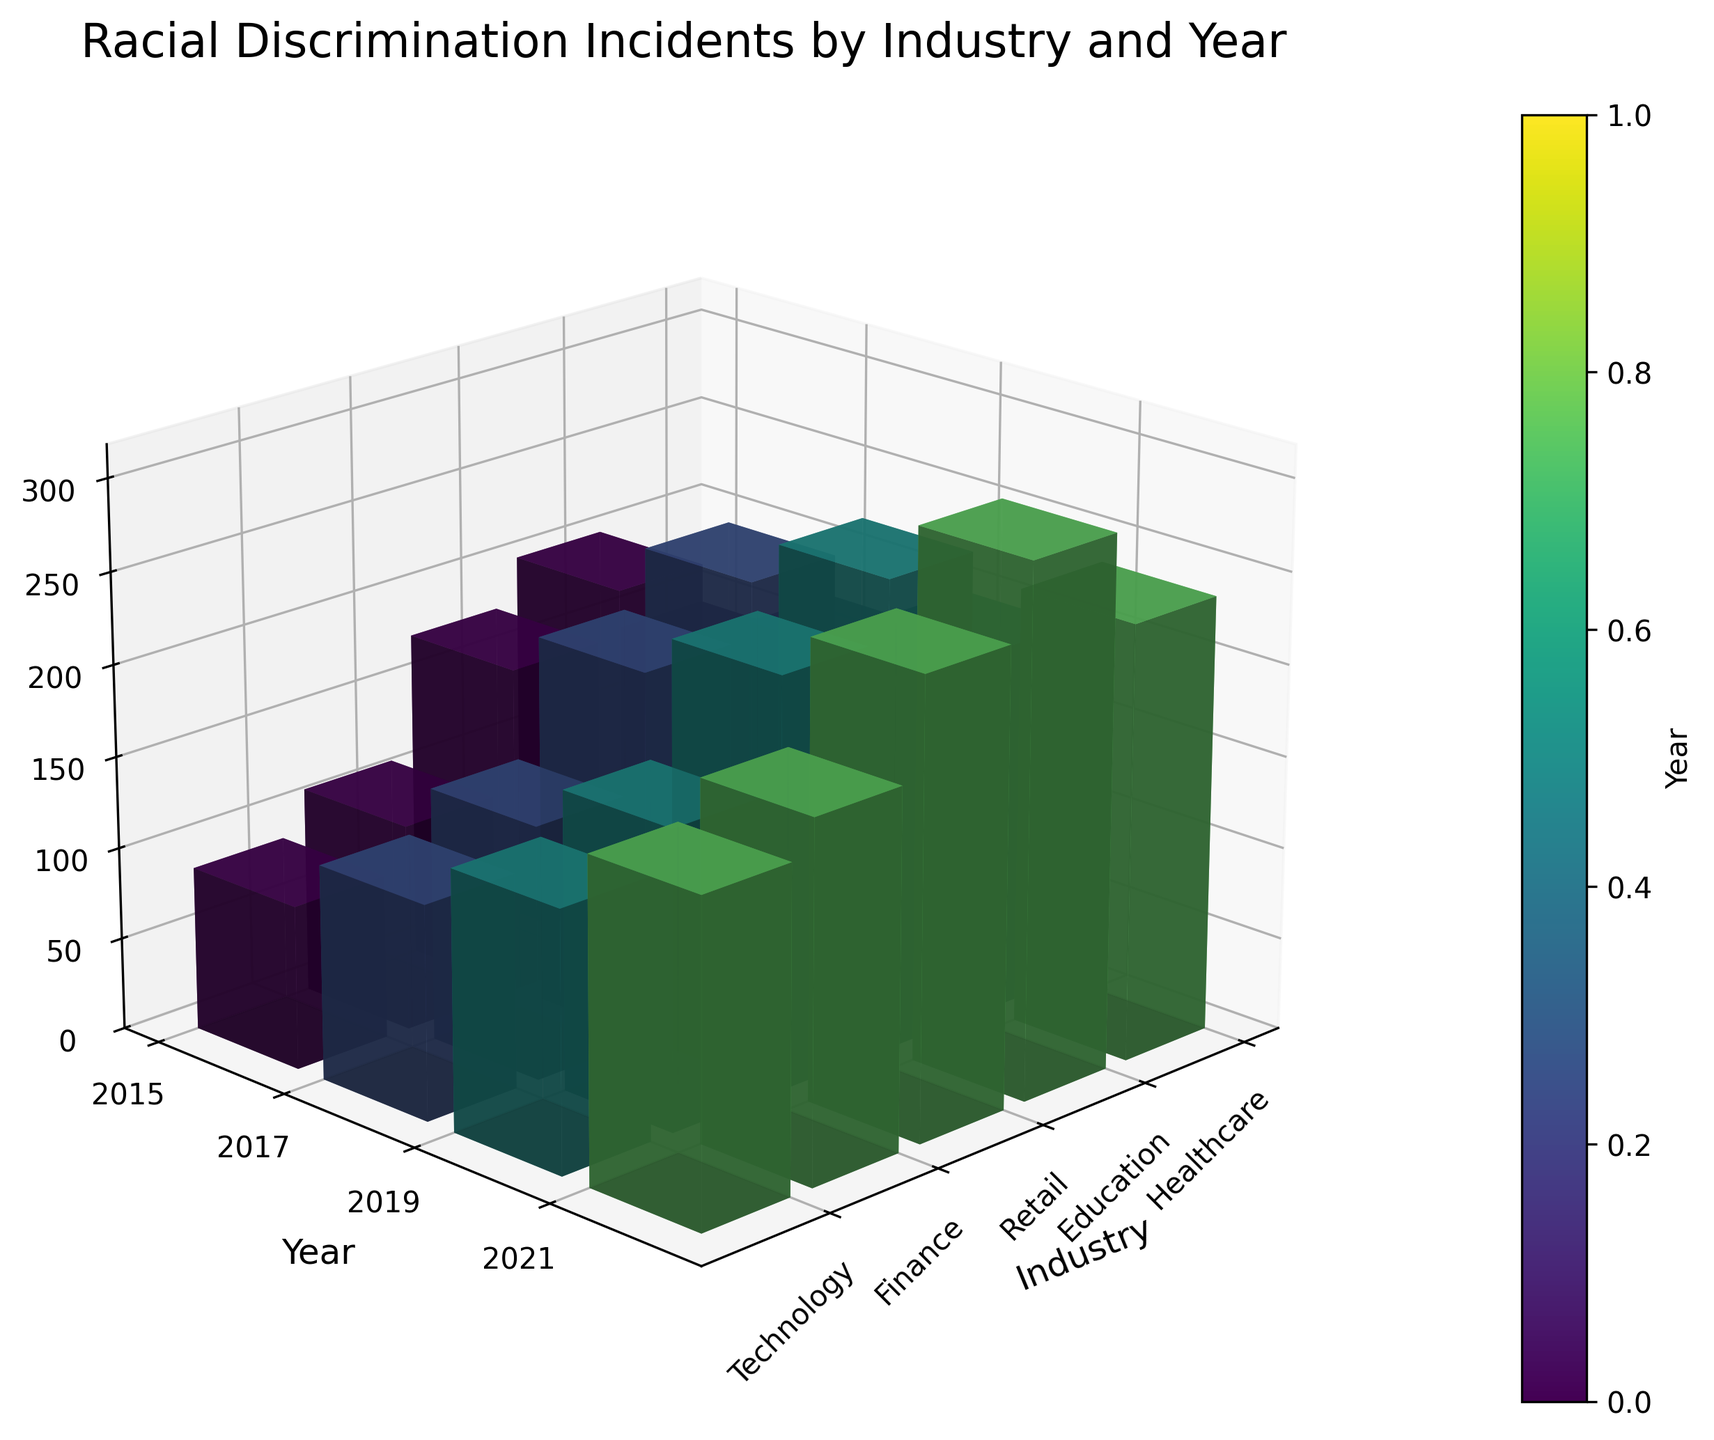What is the title of the plot? The title is usually located at the top of the figure. In this case, it reads "Racial Discrimination Incidents by Industry and Year".
Answer: Racial Discrimination Incidents by Industry and Year Which industry had the highest reported incidents in 2021? By observing the height of the bars in the plot labeled 2021, Education has the highest bar among the industries.
Answer: Education How does the number of reported incidents in Technology compare between 2015 and 2021? Look at the bars for Technology in both years. In 2015, the height corresponds to 89 incidents, whereas in 2021, it is 176 incidents.
Answer: Increased Which industry saw the largest increase in reported incidents from 2015 to 2021? Calculate the difference in incidents between 2021 and 2015 for each industry. Education increased from 203 to 289 (86), Healthcare from 145 to 237 (92), Retail from 178 to 249 (71), Finance from 112 to 195 (83), and Technology from 89 to 176 (87). The largest increase was for Healthcare with a difference of 92.
Answer: Healthcare What is the color gradient used to represent the years? The colors vary in shades, going from lighter to darker tones as years progress. This suggests a gradient, most likely viridis, from 2015 to 2021.
Answer: Viridis Which year had the lowest overall reported incidents across all industries? Sum the heights of the bars for each year and compare them. 2015: 727, 2017: 859, 2019: 983, 2021: 1146. 2015 has the lowest total.
Answer: 2015 By how much did the reported incidents in Finance increase from 2015 to 2019? Finance had 112 incidents in 2015 and 163 incidents in 2019. The difference is 163 - 112 = 51.
Answer: 51 Is there any industry which reported a steady increase in incidents every recorded year? Follow the trend for each industry across the years. Healthcare (145, 172, 198, 237), Education (203, 231, 256, 289), Retail (178, 201, 224, 249), Finance (112, 138, 163, 195), and Technology (89, 117, 142, 176) all show steady increases. However, Education reports increases every recorded year.
Answer: Education What is the range of reported incidents across all industries in 2017? In 2017, the reported incidents for Healthcare, Education, Retail, Finance, and Technology are 172, 231, 201, 138, and 117 respectively. The range is 231 (maximum) - 117 (minimum) = 114.
Answer: 114 